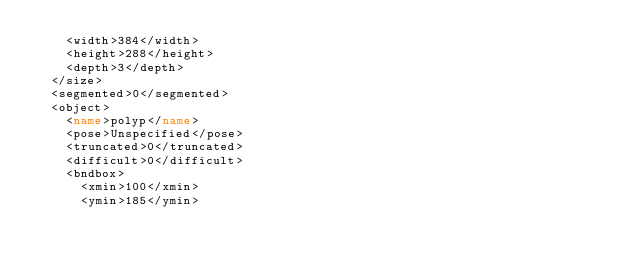<code> <loc_0><loc_0><loc_500><loc_500><_XML_>		<width>384</width>
		<height>288</height>
		<depth>3</depth>
	</size>
	<segmented>0</segmented>
	<object>
		<name>polyp</name>
		<pose>Unspecified</pose>
		<truncated>0</truncated>
		<difficult>0</difficult>
		<bndbox>
			<xmin>100</xmin>
			<ymin>185</ymin></code> 